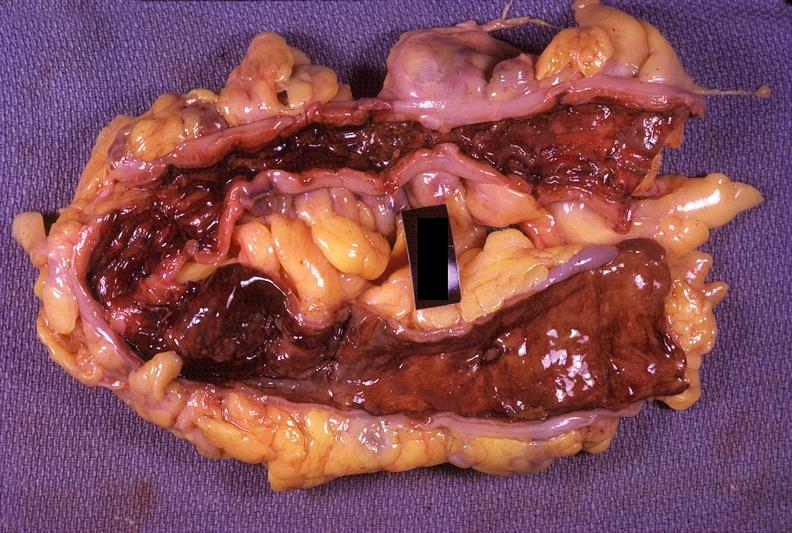s cardiovascular present?
Answer the question using a single word or phrase. No 